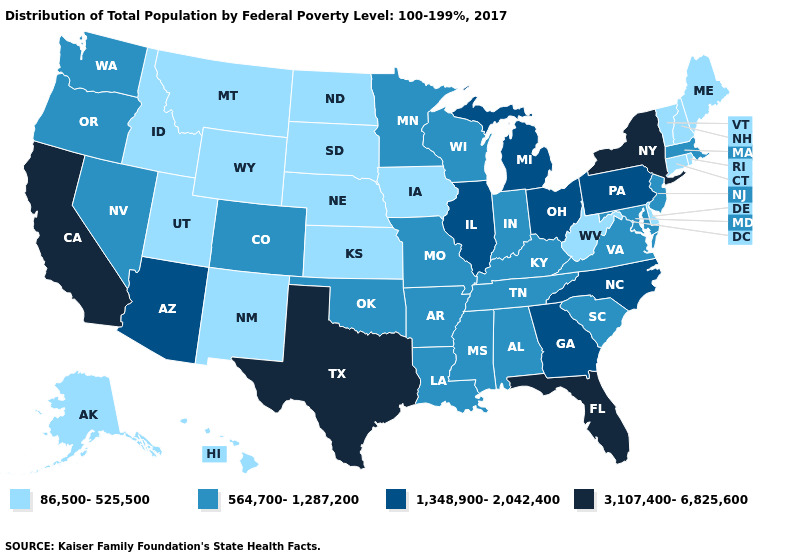Among the states that border Washington , does Idaho have the highest value?
Answer briefly. No. Does Illinois have the highest value in the MidWest?
Answer briefly. Yes. What is the value of Alabama?
Concise answer only. 564,700-1,287,200. What is the lowest value in the South?
Quick response, please. 86,500-525,500. Does Texas have the highest value in the USA?
Short answer required. Yes. What is the highest value in states that border Virginia?
Quick response, please. 1,348,900-2,042,400. Name the states that have a value in the range 3,107,400-6,825,600?
Write a very short answer. California, Florida, New York, Texas. Does Minnesota have a higher value than New Jersey?
Concise answer only. No. What is the value of Montana?
Short answer required. 86,500-525,500. Name the states that have a value in the range 86,500-525,500?
Write a very short answer. Alaska, Connecticut, Delaware, Hawaii, Idaho, Iowa, Kansas, Maine, Montana, Nebraska, New Hampshire, New Mexico, North Dakota, Rhode Island, South Dakota, Utah, Vermont, West Virginia, Wyoming. What is the value of Minnesota?
Write a very short answer. 564,700-1,287,200. Among the states that border South Dakota , which have the lowest value?
Answer briefly. Iowa, Montana, Nebraska, North Dakota, Wyoming. What is the highest value in the USA?
Give a very brief answer. 3,107,400-6,825,600. Which states have the highest value in the USA?
Answer briefly. California, Florida, New York, Texas. What is the highest value in states that border Washington?
Short answer required. 564,700-1,287,200. 